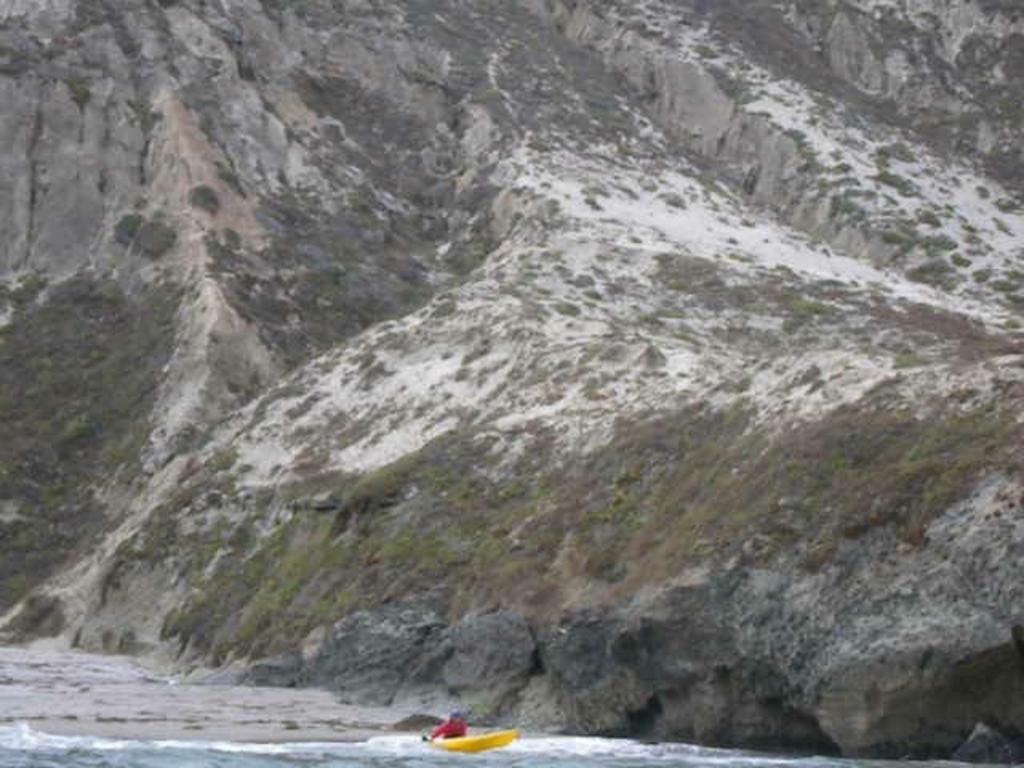Could you give a brief overview of what you see in this image? In the picture I can see a person is sitting in the yellow color boat which is floating on the water. In the background, I can see the mountains. 